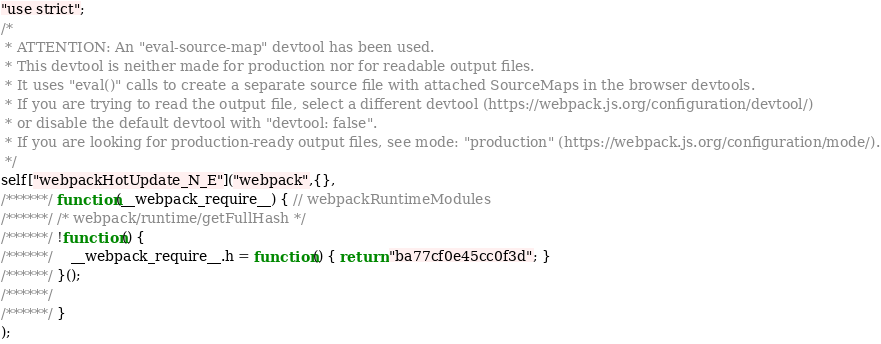Convert code to text. <code><loc_0><loc_0><loc_500><loc_500><_JavaScript_>"use strict";
/*
 * ATTENTION: An "eval-source-map" devtool has been used.
 * This devtool is neither made for production nor for readable output files.
 * It uses "eval()" calls to create a separate source file with attached SourceMaps in the browser devtools.
 * If you are trying to read the output file, select a different devtool (https://webpack.js.org/configuration/devtool/)
 * or disable the default devtool with "devtool: false".
 * If you are looking for production-ready output files, see mode: "production" (https://webpack.js.org/configuration/mode/).
 */
self["webpackHotUpdate_N_E"]("webpack",{},
/******/ function(__webpack_require__) { // webpackRuntimeModules
/******/ /* webpack/runtime/getFullHash */
/******/ !function() {
/******/ 	__webpack_require__.h = function() { return "ba77cf0e45cc0f3d"; }
/******/ }();
/******/ 
/******/ }
);</code> 